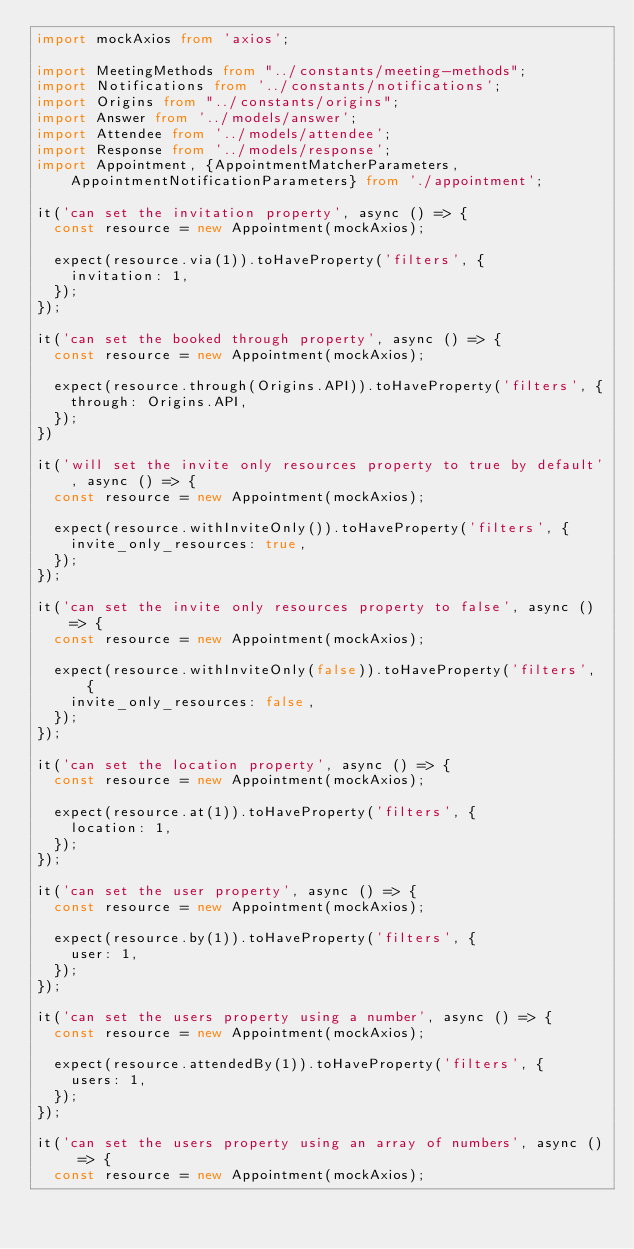<code> <loc_0><loc_0><loc_500><loc_500><_TypeScript_>import mockAxios from 'axios';

import MeetingMethods from "../constants/meeting-methods";
import Notifications from '../constants/notifications';
import Origins from "../constants/origins";
import Answer from '../models/answer';
import Attendee from '../models/attendee';
import Response from '../models/response';
import Appointment, {AppointmentMatcherParameters, AppointmentNotificationParameters} from './appointment';

it('can set the invitation property', async () => {
  const resource = new Appointment(mockAxios);

  expect(resource.via(1)).toHaveProperty('filters', {
    invitation: 1,
  });
});

it('can set the booked through property', async () => {
  const resource = new Appointment(mockAxios);

  expect(resource.through(Origins.API)).toHaveProperty('filters', {
    through: Origins.API,
  });
})

it('will set the invite only resources property to true by default', async () => {
  const resource = new Appointment(mockAxios);

  expect(resource.withInviteOnly()).toHaveProperty('filters', {
    invite_only_resources: true,
  });
});

it('can set the invite only resources property to false', async () => {
  const resource = new Appointment(mockAxios);

  expect(resource.withInviteOnly(false)).toHaveProperty('filters', {
    invite_only_resources: false,
  });
});

it('can set the location property', async () => {
  const resource = new Appointment(mockAxios);

  expect(resource.at(1)).toHaveProperty('filters', {
    location: 1,
  });
});

it('can set the user property', async () => {
  const resource = new Appointment(mockAxios);

  expect(resource.by(1)).toHaveProperty('filters', {
    user: 1,
  });
});

it('can set the users property using a number', async () => {
  const resource = new Appointment(mockAxios);

  expect(resource.attendedBy(1)).toHaveProperty('filters', {
    users: 1,
  });
});

it('can set the users property using an array of numbers', async () => {
  const resource = new Appointment(mockAxios);
</code> 